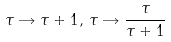<formula> <loc_0><loc_0><loc_500><loc_500>\tau \rightarrow \tau + 1 , \, \tau \rightarrow \frac { \tau } { \tau + 1 }</formula> 